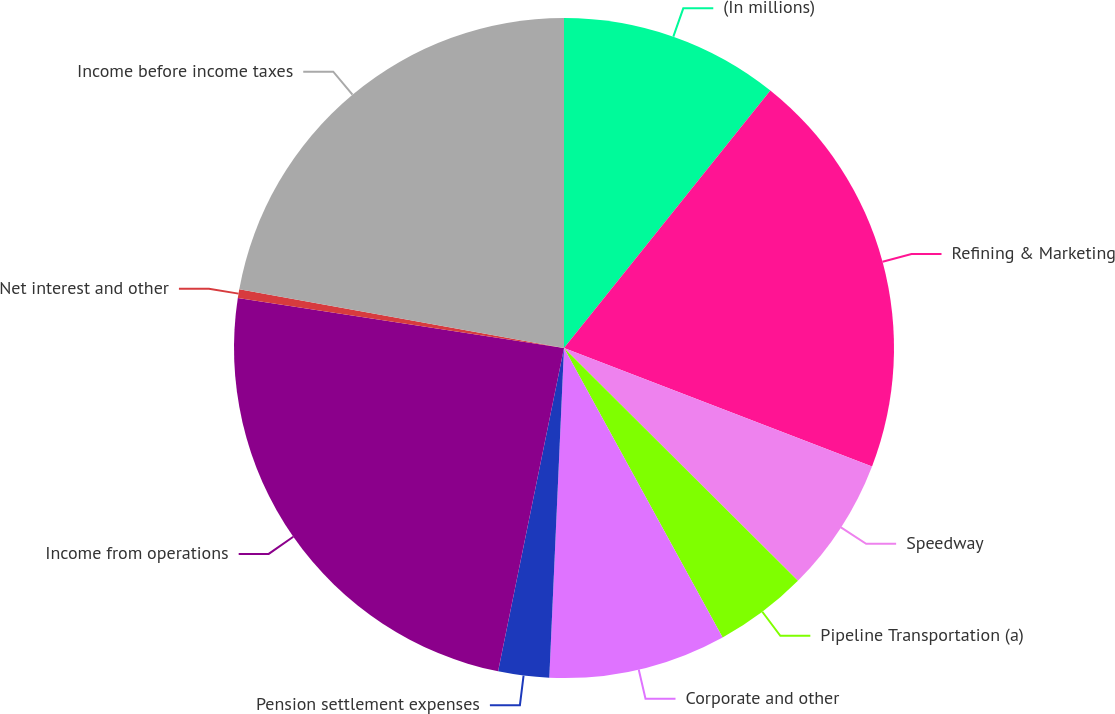Convert chart to OTSL. <chart><loc_0><loc_0><loc_500><loc_500><pie_chart><fcel>(In millions)<fcel>Refining & Marketing<fcel>Speedway<fcel>Pipeline Transportation (a)<fcel>Corporate and other<fcel>Pension settlement expenses<fcel>Income from operations<fcel>Net interest and other<fcel>Income before income taxes<nl><fcel>10.75%<fcel>20.09%<fcel>6.62%<fcel>4.56%<fcel>8.69%<fcel>2.49%<fcel>24.22%<fcel>0.43%<fcel>22.15%<nl></chart> 